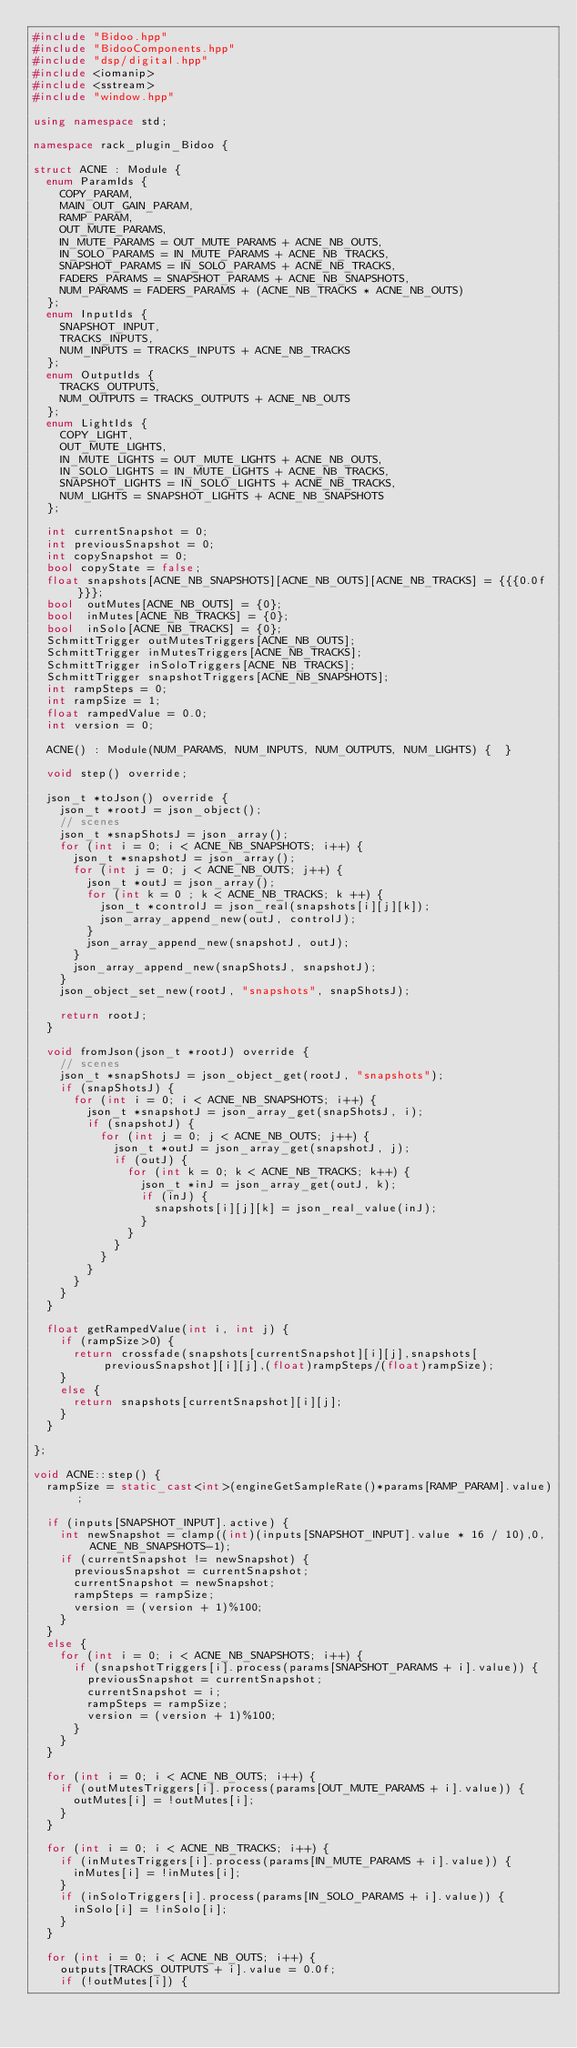Convert code to text. <code><loc_0><loc_0><loc_500><loc_500><_C++_>#include "Bidoo.hpp"
#include "BidooComponents.hpp"
#include "dsp/digital.hpp"
#include <iomanip>
#include <sstream>
#include "window.hpp"

using namespace std;

namespace rack_plugin_Bidoo {

struct ACNE : Module {
	enum ParamIds {
	  COPY_PARAM,
		MAIN_OUT_GAIN_PARAM,
		RAMP_PARAM,
		OUT_MUTE_PARAMS,
		IN_MUTE_PARAMS = OUT_MUTE_PARAMS + ACNE_NB_OUTS,
		IN_SOLO_PARAMS = IN_MUTE_PARAMS + ACNE_NB_TRACKS,
		SNAPSHOT_PARAMS = IN_SOLO_PARAMS + ACNE_NB_TRACKS,
		FADERS_PARAMS = SNAPSHOT_PARAMS + ACNE_NB_SNAPSHOTS,
		NUM_PARAMS = FADERS_PARAMS + (ACNE_NB_TRACKS * ACNE_NB_OUTS)
	};
	enum InputIds {
		SNAPSHOT_INPUT,
		TRACKS_INPUTS,
		NUM_INPUTS = TRACKS_INPUTS + ACNE_NB_TRACKS
	};
	enum OutputIds {
		TRACKS_OUTPUTS,
		NUM_OUTPUTS = TRACKS_OUTPUTS + ACNE_NB_OUTS
	};
	enum LightIds {
		COPY_LIGHT,
		OUT_MUTE_LIGHTS,
		IN_MUTE_LIGHTS = OUT_MUTE_LIGHTS + ACNE_NB_OUTS,
		IN_SOLO_LIGHTS = IN_MUTE_LIGHTS + ACNE_NB_TRACKS,
		SNAPSHOT_LIGHTS = IN_SOLO_LIGHTS + ACNE_NB_TRACKS,
		NUM_LIGHTS = SNAPSHOT_LIGHTS + ACNE_NB_SNAPSHOTS
	};

	int currentSnapshot = 0;
	int previousSnapshot = 0;
	int copySnapshot = 0;
	bool copyState = false;
	float snapshots[ACNE_NB_SNAPSHOTS][ACNE_NB_OUTS][ACNE_NB_TRACKS] = {{{0.0f}}};
	bool  outMutes[ACNE_NB_OUTS] = {0};
	bool  inMutes[ACNE_NB_TRACKS] = {0};
	bool  inSolo[ACNE_NB_TRACKS] = {0};
	SchmittTrigger outMutesTriggers[ACNE_NB_OUTS];
	SchmittTrigger inMutesTriggers[ACNE_NB_TRACKS];
	SchmittTrigger inSoloTriggers[ACNE_NB_TRACKS];
	SchmittTrigger snapshotTriggers[ACNE_NB_SNAPSHOTS];
	int rampSteps = 0;
	int rampSize = 1;
	float rampedValue = 0.0;
	int version = 0;

	ACNE() : Module(NUM_PARAMS, NUM_INPUTS, NUM_OUTPUTS, NUM_LIGHTS) {	}

	void step() override;

	json_t *toJson() override {
		json_t *rootJ = json_object();
		// scenes
		json_t *snapShotsJ = json_array();
		for (int i = 0; i < ACNE_NB_SNAPSHOTS; i++) {
			json_t *snapshotJ = json_array();
			for (int j = 0; j < ACNE_NB_OUTS; j++) {
				json_t *outJ = json_array();
				for (int k = 0 ; k < ACNE_NB_TRACKS; k ++) {
					json_t *controlJ = json_real(snapshots[i][j][k]);
					json_array_append_new(outJ, controlJ);
				}
				json_array_append_new(snapshotJ, outJ);
			}
			json_array_append_new(snapShotsJ, snapshotJ);
		}
		json_object_set_new(rootJ, "snapshots", snapShotsJ);

		return rootJ;
	}

	void fromJson(json_t *rootJ) override {
		// scenes
		json_t *snapShotsJ = json_object_get(rootJ, "snapshots");
		if (snapShotsJ) {
			for (int i = 0; i < ACNE_NB_SNAPSHOTS; i++) {
				json_t *snapshotJ = json_array_get(snapShotsJ, i);
				if (snapshotJ) {
					for (int j = 0; j < ACNE_NB_OUTS; j++) {
						json_t *outJ = json_array_get(snapshotJ, j);
						if (outJ) {
							for (int k = 0; k < ACNE_NB_TRACKS; k++) {
								json_t *inJ = json_array_get(outJ, k);
								if (inJ) {
									snapshots[i][j][k] = json_real_value(inJ);
								}
							}
						}
					}
				}
			}
		}
	}

	float getRampedValue(int i, int j) {
		if (rampSize>0) {
			return crossfade(snapshots[currentSnapshot][i][j],snapshots[previousSnapshot][i][j],(float)rampSteps/(float)rampSize);
		}
		else {
			return snapshots[currentSnapshot][i][j];
		}
	}

};

void ACNE::step() {
	rampSize = static_cast<int>(engineGetSampleRate()*params[RAMP_PARAM].value);

	if (inputs[SNAPSHOT_INPUT].active) {
		int newSnapshot = clamp((int)(inputs[SNAPSHOT_INPUT].value * 16 / 10),0,ACNE_NB_SNAPSHOTS-1);
		if (currentSnapshot != newSnapshot) {
			previousSnapshot = currentSnapshot;
			currentSnapshot = newSnapshot;
			rampSteps = rampSize;
			version = (version + 1)%100;
		}
	}
	else {
		for (int i = 0; i < ACNE_NB_SNAPSHOTS; i++) {
			if (snapshotTriggers[i].process(params[SNAPSHOT_PARAMS + i].value)) {
				previousSnapshot = currentSnapshot;
				currentSnapshot = i;
				rampSteps = rampSize;
				version = (version + 1)%100;
			}
		}
	}

	for (int i = 0; i < ACNE_NB_OUTS; i++) {
		if (outMutesTriggers[i].process(params[OUT_MUTE_PARAMS + i].value)) {
			outMutes[i] = !outMutes[i];
		}
	}

	for (int i = 0; i < ACNE_NB_TRACKS; i++) {
		if (inMutesTriggers[i].process(params[IN_MUTE_PARAMS + i].value)) {
			inMutes[i] = !inMutes[i];
		}
		if (inSoloTriggers[i].process(params[IN_SOLO_PARAMS + i].value)) {
			inSolo[i] = !inSolo[i];
		}
	}

	for (int i = 0; i < ACNE_NB_OUTS; i++) {
		outputs[TRACKS_OUTPUTS + i].value = 0.0f;
		if (!outMutes[i]) {</code> 